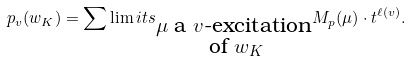Convert formula to latex. <formula><loc_0><loc_0><loc_500><loc_500>p _ { v } ( w _ { K } ) = \sum \lim i t s _ { \substack { \mu \text { a $v$-excitation} \\ \text { of } w _ { K } } } M _ { p } ( \mu ) \cdot t ^ { \ell ( v ) } .</formula> 